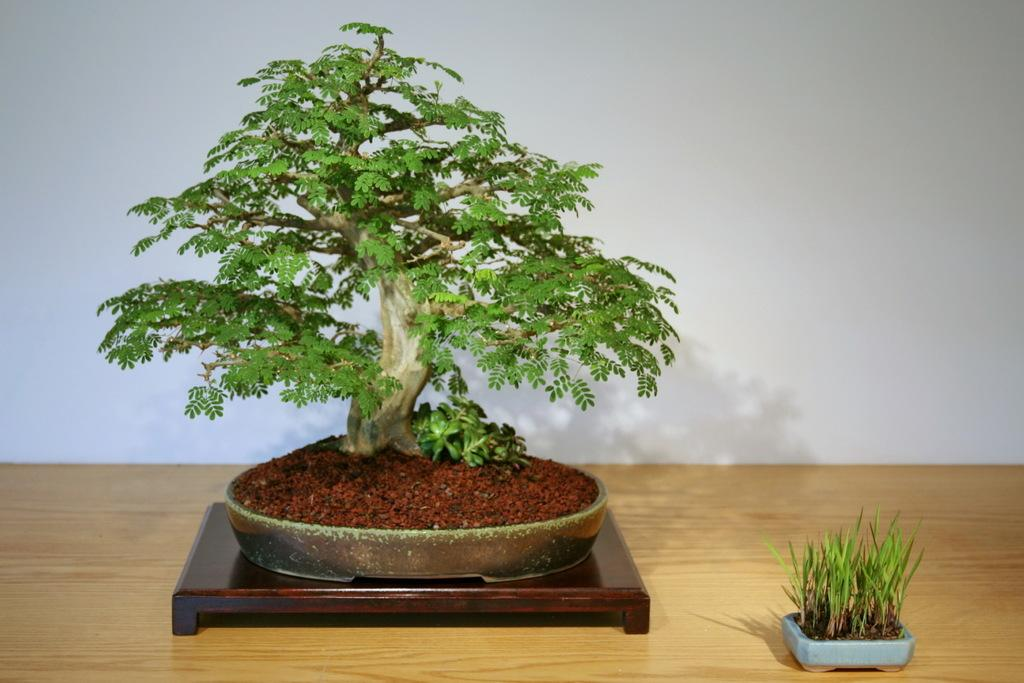What is located on the wooden surface in the image? There is a tree on a wooden surface in the image. What other type of plant can be seen in the image? There is a plant in the image. What is the color of the wall in the image? There is a white wall in the image. What type of brass instrument is being played in the image? There is no brass instrument present in the image; it features a tree on a wooden surface, a plant, and a white wall. What color is the coat worn by the person in the image? There is no person or coat present in the image. 